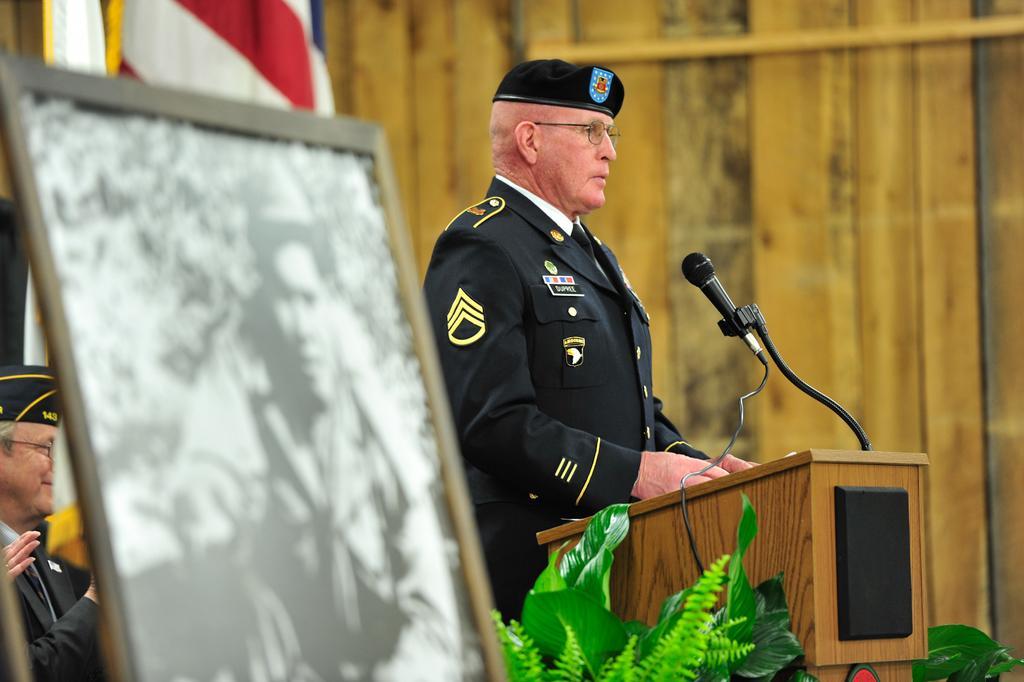Could you give a brief overview of what you see in this image? On the left side of the image we can see one photo frame. On the photo frame, we can see one person and a few other objects. In the center of the image, we can see one person standing and he is wearing a cap and glasses and he is in different costume. In front of him, we can see one wooden stand, microphone, wire, plants, etc. In the background there is a wooden wall, one flag and a few other objects. And we can see one person sitting and he is smiling and he is wearing a cap and glasses. Behind him, we can see one human hand. 